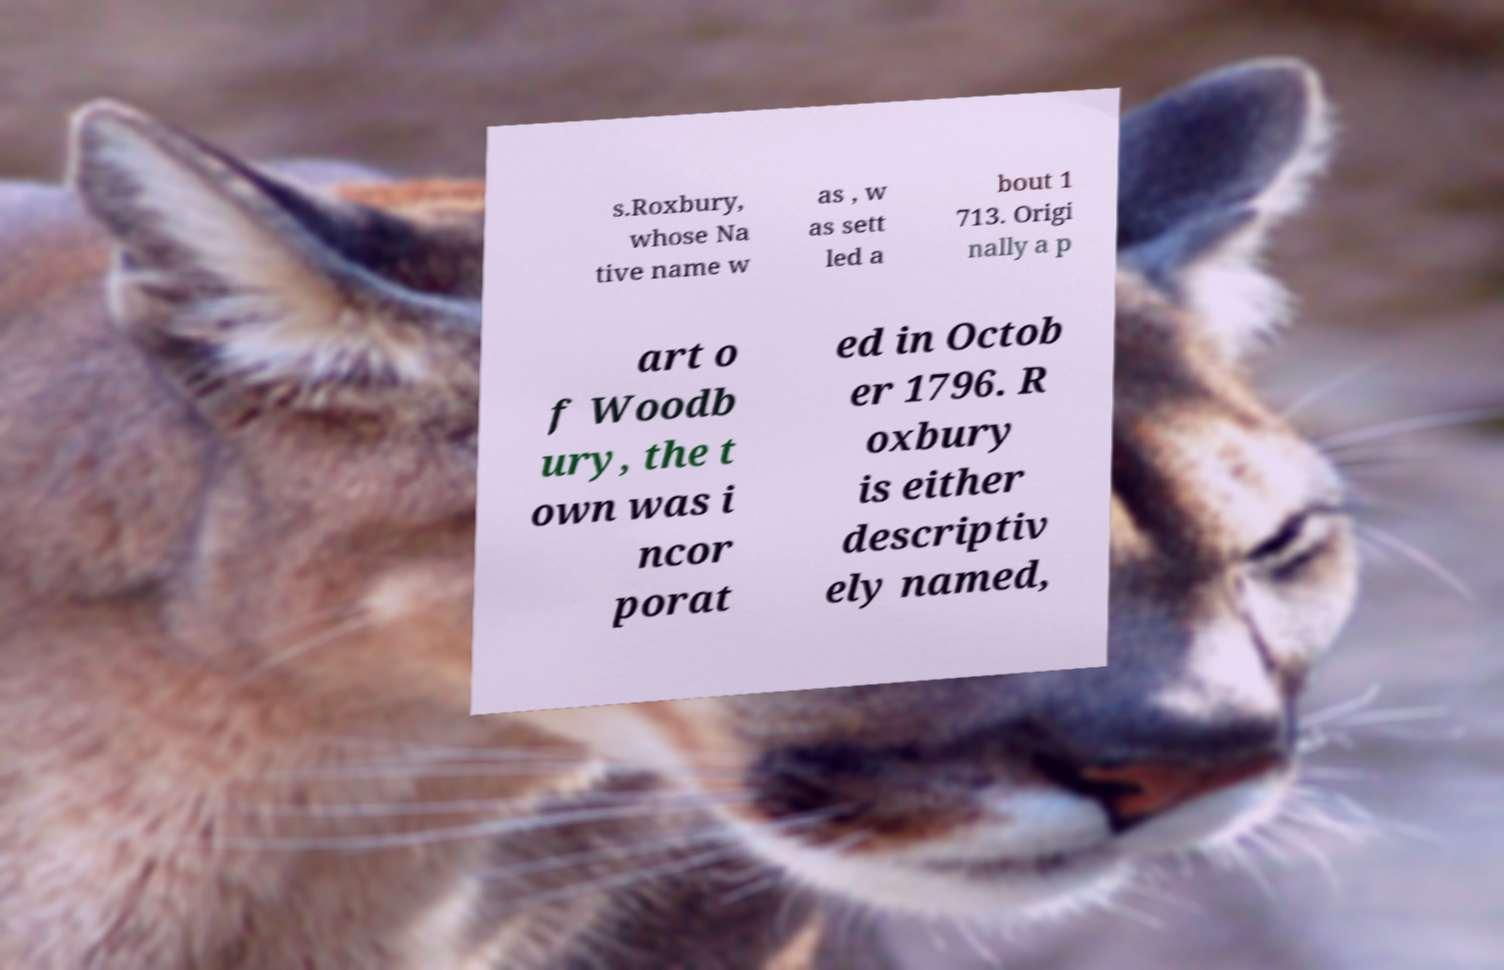Please read and relay the text visible in this image. What does it say? s.Roxbury, whose Na tive name w as , w as sett led a bout 1 713. Origi nally a p art o f Woodb ury, the t own was i ncor porat ed in Octob er 1796. R oxbury is either descriptiv ely named, 